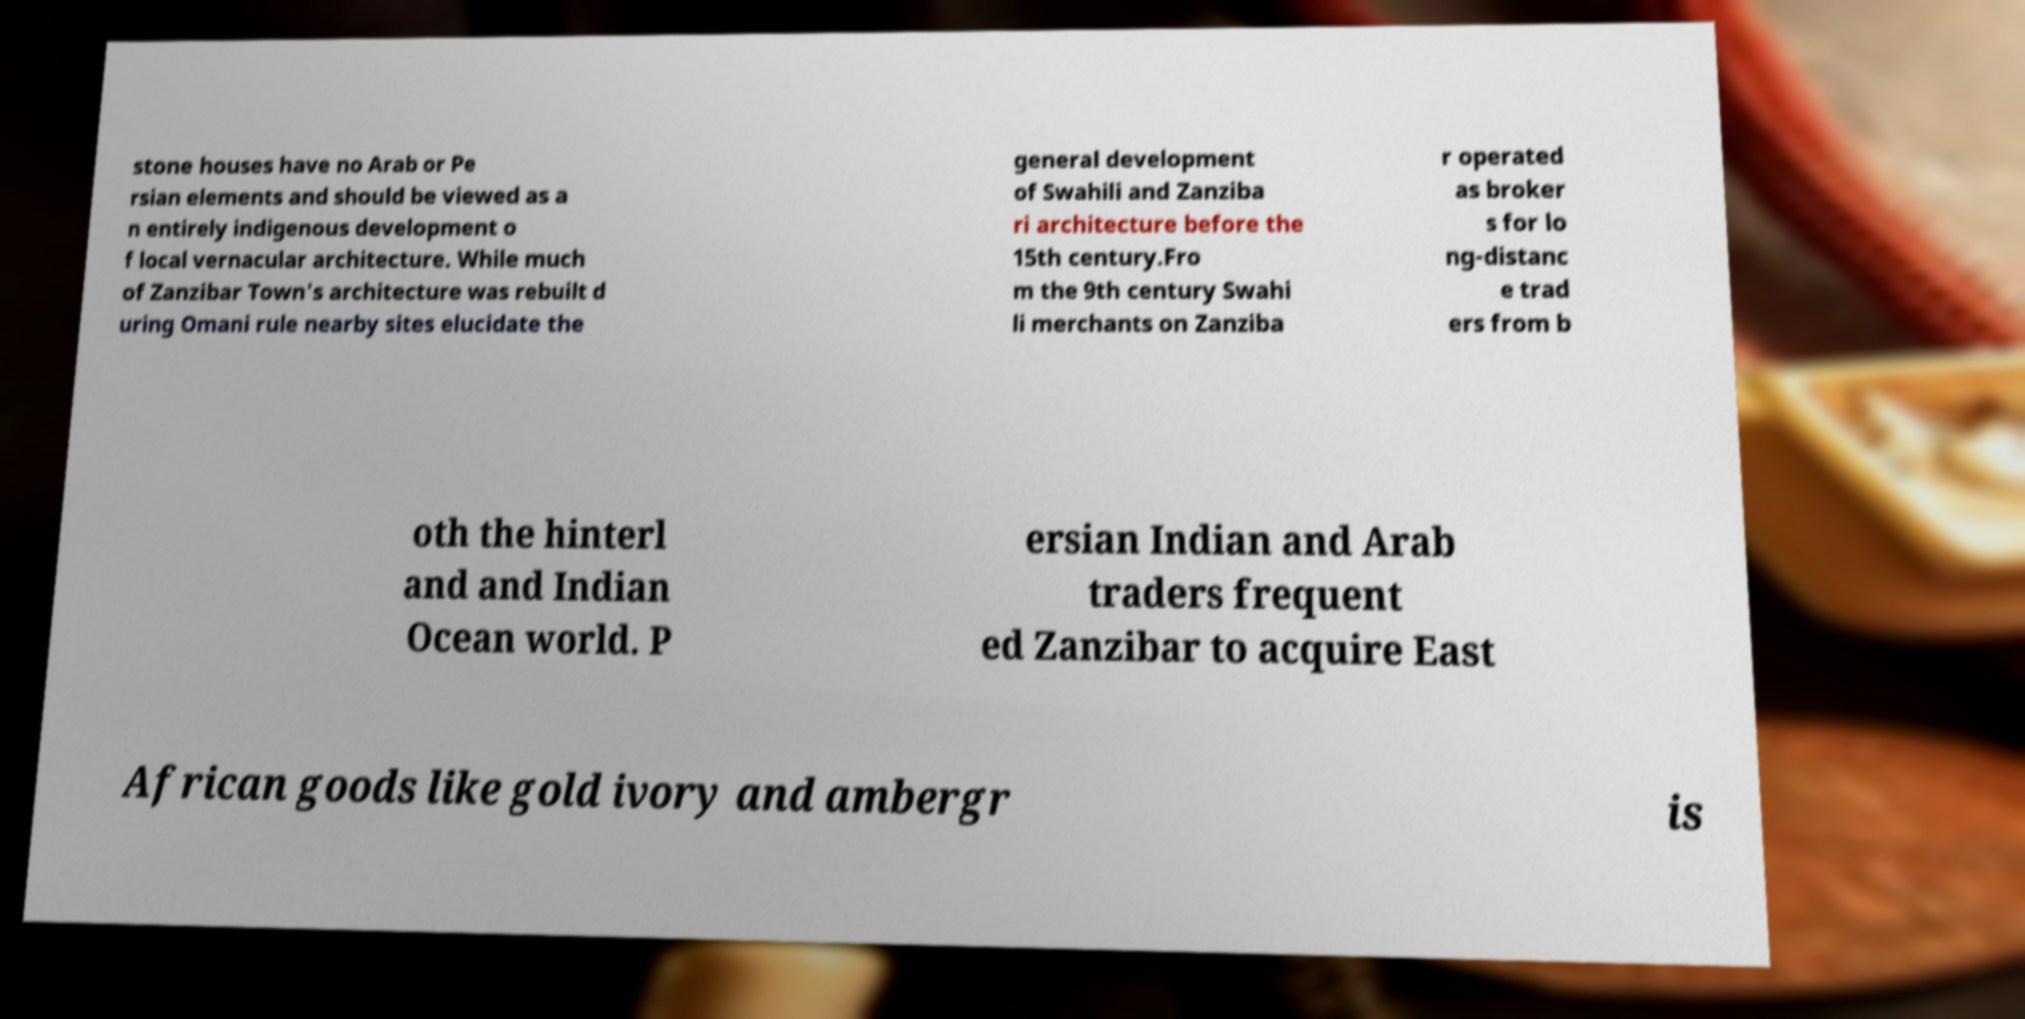Please identify and transcribe the text found in this image. stone houses have no Arab or Pe rsian elements and should be viewed as a n entirely indigenous development o f local vernacular architecture. While much of Zanzibar Town's architecture was rebuilt d uring Omani rule nearby sites elucidate the general development of Swahili and Zanziba ri architecture before the 15th century.Fro m the 9th century Swahi li merchants on Zanziba r operated as broker s for lo ng-distanc e trad ers from b oth the hinterl and and Indian Ocean world. P ersian Indian and Arab traders frequent ed Zanzibar to acquire East African goods like gold ivory and ambergr is 